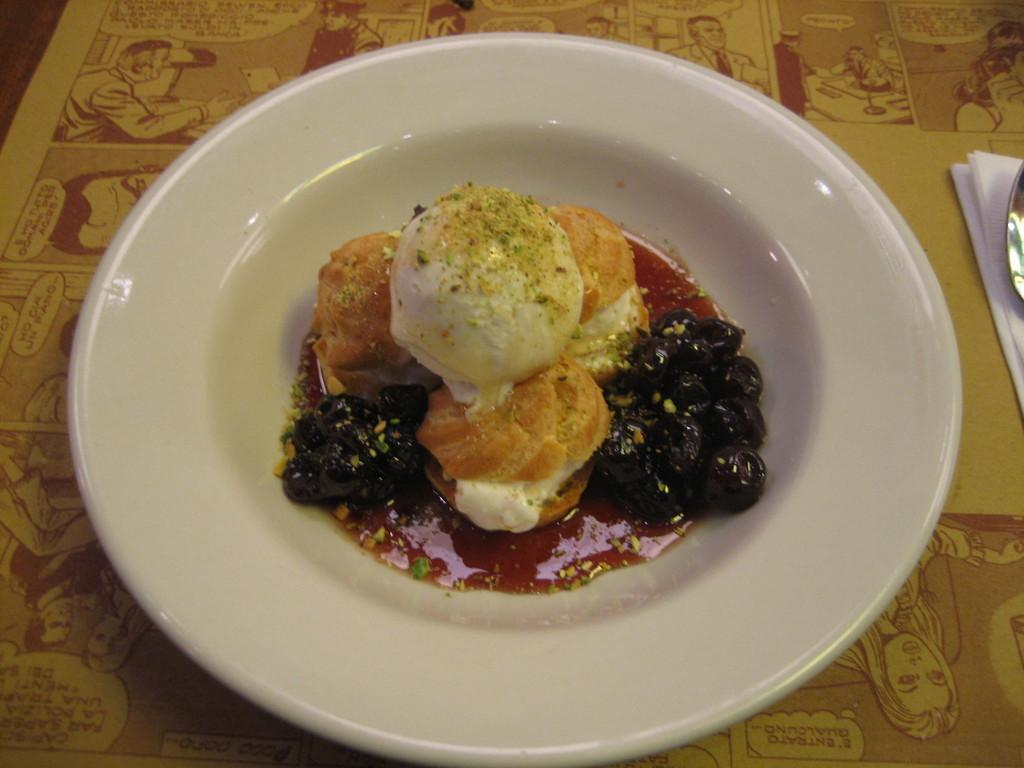What is on the plate in the image? There is a food item on a plate in the image. What is located beside the plate? There is a tissue and a spoon beside the plate. Can you see a kitten playing with a baseball beside the plate in the image? No, there is no kitten or baseball present in the image. 